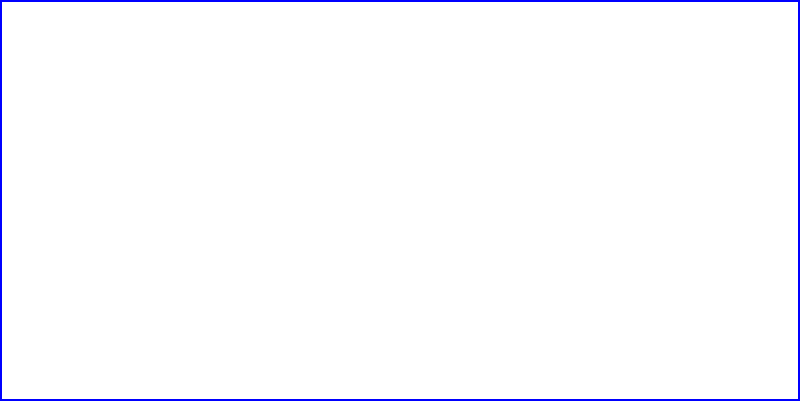Look at the shape above. If you fold this flat shape along the dashed lines, what 3D object will you create? Let's break this down step-by-step:

1. The blue shape is a flat rectangle. This is our starting point.

2. The dashed lines show where we need to fold the shape.

3. There are four vertical dashed lines, one at each corner of the rectangle.

4. When we fold along these lines, the flat shape will become a box-like object.

5. The bottom of the box is the original blue rectangle.

6. The top of the box is shown by the solid lines at the top of the image.

7. When folded, the shape will have six faces: top, bottom, front, back, left, and right.

8. All of these faces are rectangles.

9. A three-dimensional object with six rectangular faces is called a rectangular prism or a cuboid.

Therefore, when folded, this flat shape will become a rectangular prism.
Answer: Rectangular prism 